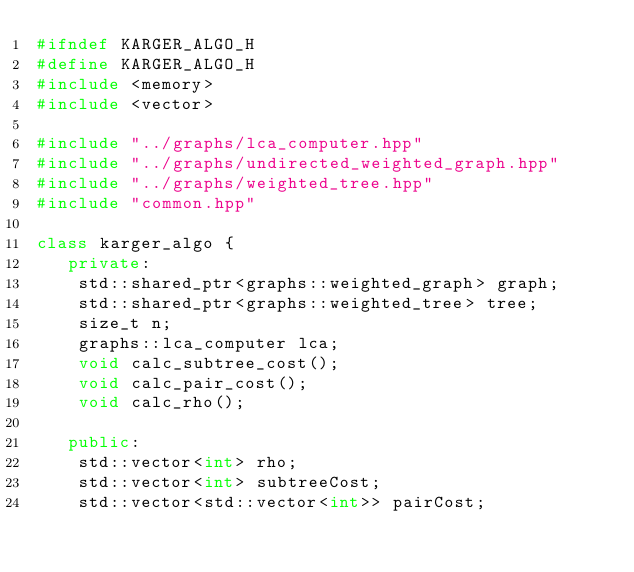<code> <loc_0><loc_0><loc_500><loc_500><_C++_>#ifndef KARGER_ALGO_H
#define KARGER_ALGO_H
#include <memory>
#include <vector>

#include "../graphs/lca_computer.hpp"
#include "../graphs/undirected_weighted_graph.hpp"
#include "../graphs/weighted_tree.hpp"
#include "common.hpp"

class karger_algo {
   private:
    std::shared_ptr<graphs::weighted_graph> graph;
    std::shared_ptr<graphs::weighted_tree> tree;
    size_t n;
    graphs::lca_computer lca;
    void calc_subtree_cost();
    void calc_pair_cost();
    void calc_rho();

   public:
    std::vector<int> rho;
    std::vector<int> subtreeCost;
    std::vector<std::vector<int>> pairCost;</code> 